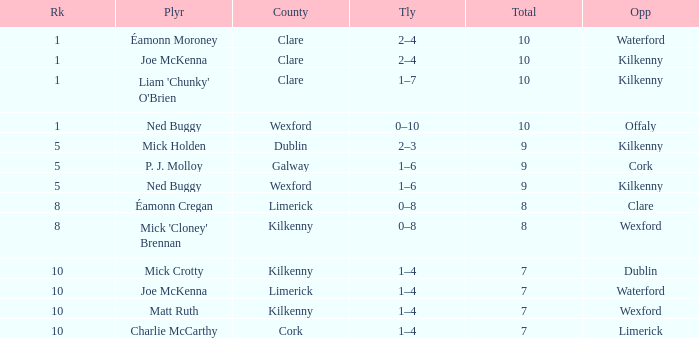Which Total has a County of kilkenny, and a Tally of 1–4, and a Rank larger than 10? None. 